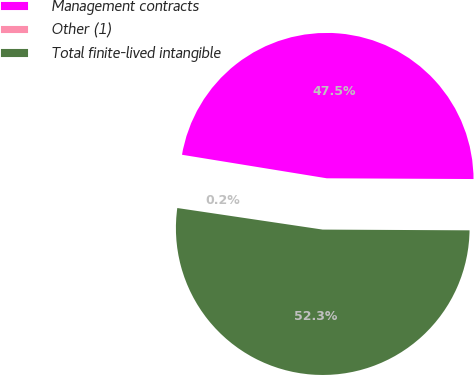Convert chart. <chart><loc_0><loc_0><loc_500><loc_500><pie_chart><fcel>Management contracts<fcel>Other (1)<fcel>Total finite-lived intangible<nl><fcel>47.51%<fcel>0.22%<fcel>52.26%<nl></chart> 